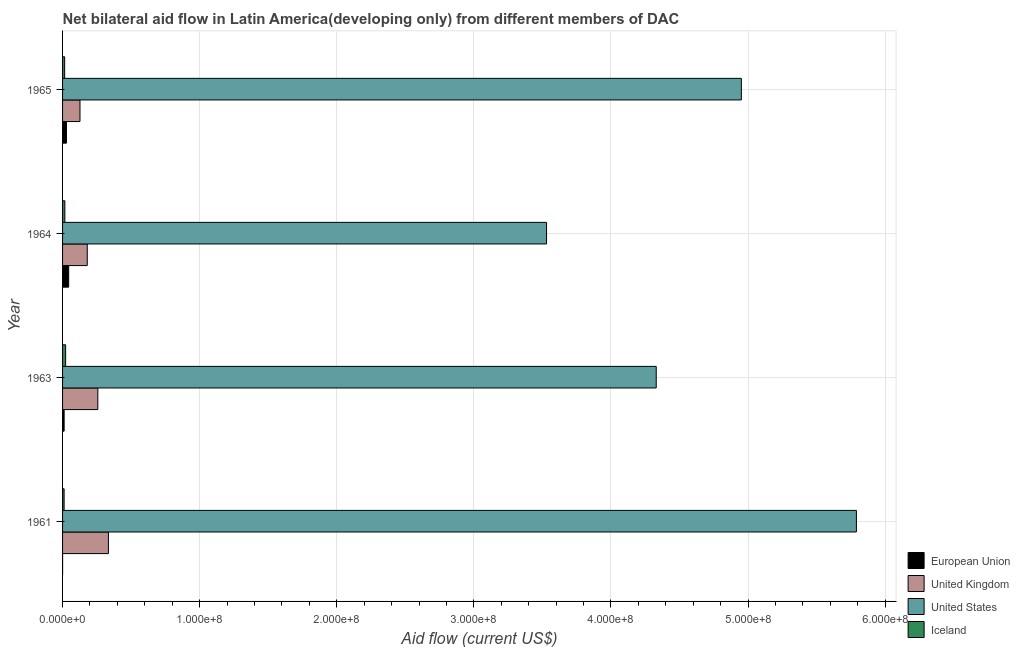Are the number of bars per tick equal to the number of legend labels?
Keep it short and to the point. Yes. Are the number of bars on each tick of the Y-axis equal?
Ensure brevity in your answer.  Yes. What is the label of the 2nd group of bars from the top?
Provide a succinct answer. 1964. In how many cases, is the number of bars for a given year not equal to the number of legend labels?
Make the answer very short. 0. What is the amount of aid given by us in 1965?
Provide a succinct answer. 4.95e+08. Across all years, what is the maximum amount of aid given by iceland?
Ensure brevity in your answer.  2.23e+06. Across all years, what is the minimum amount of aid given by iceland?
Your answer should be very brief. 1.13e+06. In which year was the amount of aid given by eu minimum?
Make the answer very short. 1961. What is the total amount of aid given by uk in the graph?
Your response must be concise. 8.99e+07. What is the difference between the amount of aid given by eu in 1964 and that in 1965?
Offer a terse response. 1.60e+06. What is the difference between the amount of aid given by uk in 1965 and the amount of aid given by eu in 1961?
Provide a succinct answer. 1.27e+07. What is the average amount of aid given by us per year?
Make the answer very short. 4.65e+08. In the year 1965, what is the difference between the amount of aid given by uk and amount of aid given by eu?
Your answer should be compact. 9.86e+06. In how many years, is the amount of aid given by uk greater than 440000000 US$?
Your answer should be compact. 0. What is the ratio of the amount of aid given by us in 1961 to that in 1964?
Your answer should be very brief. 1.64. Is the amount of aid given by us in 1961 less than that in 1965?
Your answer should be very brief. No. Is the difference between the amount of aid given by iceland in 1964 and 1965 greater than the difference between the amount of aid given by uk in 1964 and 1965?
Provide a succinct answer. No. What is the difference between the highest and the second highest amount of aid given by us?
Make the answer very short. 8.39e+07. What is the difference between the highest and the lowest amount of aid given by eu?
Ensure brevity in your answer.  4.44e+06. Is it the case that in every year, the sum of the amount of aid given by uk and amount of aid given by iceland is greater than the sum of amount of aid given by us and amount of aid given by eu?
Your answer should be compact. No. What does the 1st bar from the bottom in 1964 represents?
Keep it short and to the point. European Union. Is it the case that in every year, the sum of the amount of aid given by eu and amount of aid given by uk is greater than the amount of aid given by us?
Make the answer very short. No. How many bars are there?
Provide a succinct answer. 16. What is the difference between two consecutive major ticks on the X-axis?
Offer a terse response. 1.00e+08. Where does the legend appear in the graph?
Provide a short and direct response. Bottom right. How many legend labels are there?
Your answer should be very brief. 4. What is the title of the graph?
Provide a succinct answer. Net bilateral aid flow in Latin America(developing only) from different members of DAC. What is the label or title of the Y-axis?
Make the answer very short. Year. What is the Aid flow (current US$) in European Union in 1961?
Give a very brief answer. 10000. What is the Aid flow (current US$) of United Kingdom in 1961?
Ensure brevity in your answer.  3.34e+07. What is the Aid flow (current US$) in United States in 1961?
Your answer should be compact. 5.79e+08. What is the Aid flow (current US$) in Iceland in 1961?
Provide a short and direct response. 1.13e+06. What is the Aid flow (current US$) of European Union in 1963?
Your response must be concise. 1.14e+06. What is the Aid flow (current US$) of United Kingdom in 1963?
Ensure brevity in your answer.  2.57e+07. What is the Aid flow (current US$) in United States in 1963?
Your answer should be very brief. 4.33e+08. What is the Aid flow (current US$) of Iceland in 1963?
Your response must be concise. 2.23e+06. What is the Aid flow (current US$) in European Union in 1964?
Your response must be concise. 4.45e+06. What is the Aid flow (current US$) in United Kingdom in 1964?
Give a very brief answer. 1.80e+07. What is the Aid flow (current US$) of United States in 1964?
Keep it short and to the point. 3.53e+08. What is the Aid flow (current US$) of Iceland in 1964?
Keep it short and to the point. 1.67e+06. What is the Aid flow (current US$) of European Union in 1965?
Your response must be concise. 2.85e+06. What is the Aid flow (current US$) in United Kingdom in 1965?
Offer a terse response. 1.27e+07. What is the Aid flow (current US$) of United States in 1965?
Offer a very short reply. 4.95e+08. What is the Aid flow (current US$) of Iceland in 1965?
Give a very brief answer. 1.53e+06. Across all years, what is the maximum Aid flow (current US$) in European Union?
Keep it short and to the point. 4.45e+06. Across all years, what is the maximum Aid flow (current US$) of United Kingdom?
Offer a very short reply. 3.34e+07. Across all years, what is the maximum Aid flow (current US$) in United States?
Ensure brevity in your answer.  5.79e+08. Across all years, what is the maximum Aid flow (current US$) of Iceland?
Your response must be concise. 2.23e+06. Across all years, what is the minimum Aid flow (current US$) of United Kingdom?
Keep it short and to the point. 1.27e+07. Across all years, what is the minimum Aid flow (current US$) in United States?
Provide a succinct answer. 3.53e+08. Across all years, what is the minimum Aid flow (current US$) in Iceland?
Provide a short and direct response. 1.13e+06. What is the total Aid flow (current US$) of European Union in the graph?
Give a very brief answer. 8.45e+06. What is the total Aid flow (current US$) in United Kingdom in the graph?
Your answer should be very brief. 8.99e+07. What is the total Aid flow (current US$) of United States in the graph?
Offer a terse response. 1.86e+09. What is the total Aid flow (current US$) of Iceland in the graph?
Keep it short and to the point. 6.56e+06. What is the difference between the Aid flow (current US$) in European Union in 1961 and that in 1963?
Make the answer very short. -1.13e+06. What is the difference between the Aid flow (current US$) of United Kingdom in 1961 and that in 1963?
Provide a short and direct response. 7.73e+06. What is the difference between the Aid flow (current US$) of United States in 1961 and that in 1963?
Your response must be concise. 1.46e+08. What is the difference between the Aid flow (current US$) in Iceland in 1961 and that in 1963?
Make the answer very short. -1.10e+06. What is the difference between the Aid flow (current US$) of European Union in 1961 and that in 1964?
Your answer should be compact. -4.44e+06. What is the difference between the Aid flow (current US$) of United Kingdom in 1961 and that in 1964?
Keep it short and to the point. 1.54e+07. What is the difference between the Aid flow (current US$) of United States in 1961 and that in 1964?
Keep it short and to the point. 2.26e+08. What is the difference between the Aid flow (current US$) in Iceland in 1961 and that in 1964?
Offer a very short reply. -5.40e+05. What is the difference between the Aid flow (current US$) of European Union in 1961 and that in 1965?
Your response must be concise. -2.84e+06. What is the difference between the Aid flow (current US$) of United Kingdom in 1961 and that in 1965?
Give a very brief answer. 2.07e+07. What is the difference between the Aid flow (current US$) of United States in 1961 and that in 1965?
Keep it short and to the point. 8.39e+07. What is the difference between the Aid flow (current US$) in Iceland in 1961 and that in 1965?
Offer a terse response. -4.00e+05. What is the difference between the Aid flow (current US$) of European Union in 1963 and that in 1964?
Provide a succinct answer. -3.31e+06. What is the difference between the Aid flow (current US$) of United Kingdom in 1963 and that in 1964?
Keep it short and to the point. 7.70e+06. What is the difference between the Aid flow (current US$) of United States in 1963 and that in 1964?
Give a very brief answer. 8.00e+07. What is the difference between the Aid flow (current US$) in Iceland in 1963 and that in 1964?
Offer a terse response. 5.60e+05. What is the difference between the Aid flow (current US$) of European Union in 1963 and that in 1965?
Offer a very short reply. -1.71e+06. What is the difference between the Aid flow (current US$) in United Kingdom in 1963 and that in 1965?
Your answer should be very brief. 1.30e+07. What is the difference between the Aid flow (current US$) in United States in 1963 and that in 1965?
Your answer should be compact. -6.21e+07. What is the difference between the Aid flow (current US$) in European Union in 1964 and that in 1965?
Give a very brief answer. 1.60e+06. What is the difference between the Aid flow (current US$) in United Kingdom in 1964 and that in 1965?
Your answer should be compact. 5.31e+06. What is the difference between the Aid flow (current US$) of United States in 1964 and that in 1965?
Ensure brevity in your answer.  -1.42e+08. What is the difference between the Aid flow (current US$) in Iceland in 1964 and that in 1965?
Make the answer very short. 1.40e+05. What is the difference between the Aid flow (current US$) in European Union in 1961 and the Aid flow (current US$) in United Kingdom in 1963?
Ensure brevity in your answer.  -2.57e+07. What is the difference between the Aid flow (current US$) in European Union in 1961 and the Aid flow (current US$) in United States in 1963?
Ensure brevity in your answer.  -4.33e+08. What is the difference between the Aid flow (current US$) in European Union in 1961 and the Aid flow (current US$) in Iceland in 1963?
Make the answer very short. -2.22e+06. What is the difference between the Aid flow (current US$) in United Kingdom in 1961 and the Aid flow (current US$) in United States in 1963?
Provide a short and direct response. -4.00e+08. What is the difference between the Aid flow (current US$) in United Kingdom in 1961 and the Aid flow (current US$) in Iceland in 1963?
Provide a short and direct response. 3.12e+07. What is the difference between the Aid flow (current US$) in United States in 1961 and the Aid flow (current US$) in Iceland in 1963?
Provide a succinct answer. 5.77e+08. What is the difference between the Aid flow (current US$) in European Union in 1961 and the Aid flow (current US$) in United Kingdom in 1964?
Make the answer very short. -1.80e+07. What is the difference between the Aid flow (current US$) in European Union in 1961 and the Aid flow (current US$) in United States in 1964?
Offer a terse response. -3.53e+08. What is the difference between the Aid flow (current US$) in European Union in 1961 and the Aid flow (current US$) in Iceland in 1964?
Offer a very short reply. -1.66e+06. What is the difference between the Aid flow (current US$) of United Kingdom in 1961 and the Aid flow (current US$) of United States in 1964?
Ensure brevity in your answer.  -3.20e+08. What is the difference between the Aid flow (current US$) in United Kingdom in 1961 and the Aid flow (current US$) in Iceland in 1964?
Make the answer very short. 3.18e+07. What is the difference between the Aid flow (current US$) of United States in 1961 and the Aid flow (current US$) of Iceland in 1964?
Ensure brevity in your answer.  5.77e+08. What is the difference between the Aid flow (current US$) in European Union in 1961 and the Aid flow (current US$) in United Kingdom in 1965?
Provide a succinct answer. -1.27e+07. What is the difference between the Aid flow (current US$) in European Union in 1961 and the Aid flow (current US$) in United States in 1965?
Your answer should be compact. -4.95e+08. What is the difference between the Aid flow (current US$) of European Union in 1961 and the Aid flow (current US$) of Iceland in 1965?
Give a very brief answer. -1.52e+06. What is the difference between the Aid flow (current US$) of United Kingdom in 1961 and the Aid flow (current US$) of United States in 1965?
Keep it short and to the point. -4.62e+08. What is the difference between the Aid flow (current US$) of United Kingdom in 1961 and the Aid flow (current US$) of Iceland in 1965?
Give a very brief answer. 3.19e+07. What is the difference between the Aid flow (current US$) of United States in 1961 and the Aid flow (current US$) of Iceland in 1965?
Provide a short and direct response. 5.77e+08. What is the difference between the Aid flow (current US$) of European Union in 1963 and the Aid flow (current US$) of United Kingdom in 1964?
Your answer should be very brief. -1.69e+07. What is the difference between the Aid flow (current US$) in European Union in 1963 and the Aid flow (current US$) in United States in 1964?
Ensure brevity in your answer.  -3.52e+08. What is the difference between the Aid flow (current US$) of European Union in 1963 and the Aid flow (current US$) of Iceland in 1964?
Offer a very short reply. -5.30e+05. What is the difference between the Aid flow (current US$) of United Kingdom in 1963 and the Aid flow (current US$) of United States in 1964?
Give a very brief answer. -3.27e+08. What is the difference between the Aid flow (current US$) of United Kingdom in 1963 and the Aid flow (current US$) of Iceland in 1964?
Provide a short and direct response. 2.40e+07. What is the difference between the Aid flow (current US$) in United States in 1963 and the Aid flow (current US$) in Iceland in 1964?
Offer a terse response. 4.31e+08. What is the difference between the Aid flow (current US$) of European Union in 1963 and the Aid flow (current US$) of United Kingdom in 1965?
Provide a succinct answer. -1.16e+07. What is the difference between the Aid flow (current US$) of European Union in 1963 and the Aid flow (current US$) of United States in 1965?
Make the answer very short. -4.94e+08. What is the difference between the Aid flow (current US$) of European Union in 1963 and the Aid flow (current US$) of Iceland in 1965?
Give a very brief answer. -3.90e+05. What is the difference between the Aid flow (current US$) in United Kingdom in 1963 and the Aid flow (current US$) in United States in 1965?
Your answer should be very brief. -4.69e+08. What is the difference between the Aid flow (current US$) in United Kingdom in 1963 and the Aid flow (current US$) in Iceland in 1965?
Give a very brief answer. 2.42e+07. What is the difference between the Aid flow (current US$) of United States in 1963 and the Aid flow (current US$) of Iceland in 1965?
Give a very brief answer. 4.31e+08. What is the difference between the Aid flow (current US$) in European Union in 1964 and the Aid flow (current US$) in United Kingdom in 1965?
Ensure brevity in your answer.  -8.26e+06. What is the difference between the Aid flow (current US$) of European Union in 1964 and the Aid flow (current US$) of United States in 1965?
Your answer should be compact. -4.91e+08. What is the difference between the Aid flow (current US$) in European Union in 1964 and the Aid flow (current US$) in Iceland in 1965?
Give a very brief answer. 2.92e+06. What is the difference between the Aid flow (current US$) of United Kingdom in 1964 and the Aid flow (current US$) of United States in 1965?
Offer a terse response. -4.77e+08. What is the difference between the Aid flow (current US$) of United Kingdom in 1964 and the Aid flow (current US$) of Iceland in 1965?
Make the answer very short. 1.65e+07. What is the difference between the Aid flow (current US$) in United States in 1964 and the Aid flow (current US$) in Iceland in 1965?
Offer a terse response. 3.51e+08. What is the average Aid flow (current US$) of European Union per year?
Make the answer very short. 2.11e+06. What is the average Aid flow (current US$) in United Kingdom per year?
Make the answer very short. 2.25e+07. What is the average Aid flow (current US$) of United States per year?
Provide a succinct answer. 4.65e+08. What is the average Aid flow (current US$) of Iceland per year?
Your answer should be compact. 1.64e+06. In the year 1961, what is the difference between the Aid flow (current US$) of European Union and Aid flow (current US$) of United Kingdom?
Provide a succinct answer. -3.34e+07. In the year 1961, what is the difference between the Aid flow (current US$) of European Union and Aid flow (current US$) of United States?
Your response must be concise. -5.79e+08. In the year 1961, what is the difference between the Aid flow (current US$) in European Union and Aid flow (current US$) in Iceland?
Offer a very short reply. -1.12e+06. In the year 1961, what is the difference between the Aid flow (current US$) in United Kingdom and Aid flow (current US$) in United States?
Offer a terse response. -5.46e+08. In the year 1961, what is the difference between the Aid flow (current US$) of United Kingdom and Aid flow (current US$) of Iceland?
Your response must be concise. 3.23e+07. In the year 1961, what is the difference between the Aid flow (current US$) of United States and Aid flow (current US$) of Iceland?
Offer a very short reply. 5.78e+08. In the year 1963, what is the difference between the Aid flow (current US$) in European Union and Aid flow (current US$) in United Kingdom?
Provide a succinct answer. -2.46e+07. In the year 1963, what is the difference between the Aid flow (current US$) of European Union and Aid flow (current US$) of United States?
Ensure brevity in your answer.  -4.32e+08. In the year 1963, what is the difference between the Aid flow (current US$) in European Union and Aid flow (current US$) in Iceland?
Provide a succinct answer. -1.09e+06. In the year 1963, what is the difference between the Aid flow (current US$) in United Kingdom and Aid flow (current US$) in United States?
Offer a very short reply. -4.07e+08. In the year 1963, what is the difference between the Aid flow (current US$) of United Kingdom and Aid flow (current US$) of Iceland?
Make the answer very short. 2.35e+07. In the year 1963, what is the difference between the Aid flow (current US$) in United States and Aid flow (current US$) in Iceland?
Make the answer very short. 4.31e+08. In the year 1964, what is the difference between the Aid flow (current US$) of European Union and Aid flow (current US$) of United Kingdom?
Provide a succinct answer. -1.36e+07. In the year 1964, what is the difference between the Aid flow (current US$) in European Union and Aid flow (current US$) in United States?
Make the answer very short. -3.49e+08. In the year 1964, what is the difference between the Aid flow (current US$) in European Union and Aid flow (current US$) in Iceland?
Give a very brief answer. 2.78e+06. In the year 1964, what is the difference between the Aid flow (current US$) in United Kingdom and Aid flow (current US$) in United States?
Ensure brevity in your answer.  -3.35e+08. In the year 1964, what is the difference between the Aid flow (current US$) of United Kingdom and Aid flow (current US$) of Iceland?
Give a very brief answer. 1.64e+07. In the year 1964, what is the difference between the Aid flow (current US$) of United States and Aid flow (current US$) of Iceland?
Your answer should be compact. 3.51e+08. In the year 1965, what is the difference between the Aid flow (current US$) in European Union and Aid flow (current US$) in United Kingdom?
Offer a terse response. -9.86e+06. In the year 1965, what is the difference between the Aid flow (current US$) of European Union and Aid flow (current US$) of United States?
Your answer should be compact. -4.92e+08. In the year 1965, what is the difference between the Aid flow (current US$) in European Union and Aid flow (current US$) in Iceland?
Ensure brevity in your answer.  1.32e+06. In the year 1965, what is the difference between the Aid flow (current US$) in United Kingdom and Aid flow (current US$) in United States?
Your answer should be compact. -4.82e+08. In the year 1965, what is the difference between the Aid flow (current US$) in United Kingdom and Aid flow (current US$) in Iceland?
Your response must be concise. 1.12e+07. In the year 1965, what is the difference between the Aid flow (current US$) of United States and Aid flow (current US$) of Iceland?
Provide a short and direct response. 4.94e+08. What is the ratio of the Aid flow (current US$) in European Union in 1961 to that in 1963?
Ensure brevity in your answer.  0.01. What is the ratio of the Aid flow (current US$) in United Kingdom in 1961 to that in 1963?
Offer a terse response. 1.3. What is the ratio of the Aid flow (current US$) in United States in 1961 to that in 1963?
Offer a terse response. 1.34. What is the ratio of the Aid flow (current US$) of Iceland in 1961 to that in 1963?
Your answer should be very brief. 0.51. What is the ratio of the Aid flow (current US$) of European Union in 1961 to that in 1964?
Your answer should be compact. 0. What is the ratio of the Aid flow (current US$) in United Kingdom in 1961 to that in 1964?
Your answer should be compact. 1.86. What is the ratio of the Aid flow (current US$) of United States in 1961 to that in 1964?
Provide a short and direct response. 1.64. What is the ratio of the Aid flow (current US$) in Iceland in 1961 to that in 1964?
Keep it short and to the point. 0.68. What is the ratio of the Aid flow (current US$) of European Union in 1961 to that in 1965?
Offer a terse response. 0. What is the ratio of the Aid flow (current US$) in United Kingdom in 1961 to that in 1965?
Your answer should be compact. 2.63. What is the ratio of the Aid flow (current US$) in United States in 1961 to that in 1965?
Make the answer very short. 1.17. What is the ratio of the Aid flow (current US$) in Iceland in 1961 to that in 1965?
Your answer should be compact. 0.74. What is the ratio of the Aid flow (current US$) in European Union in 1963 to that in 1964?
Provide a short and direct response. 0.26. What is the ratio of the Aid flow (current US$) in United Kingdom in 1963 to that in 1964?
Offer a very short reply. 1.43. What is the ratio of the Aid flow (current US$) of United States in 1963 to that in 1964?
Give a very brief answer. 1.23. What is the ratio of the Aid flow (current US$) of Iceland in 1963 to that in 1964?
Provide a succinct answer. 1.34. What is the ratio of the Aid flow (current US$) of European Union in 1963 to that in 1965?
Your response must be concise. 0.4. What is the ratio of the Aid flow (current US$) of United Kingdom in 1963 to that in 1965?
Provide a succinct answer. 2.02. What is the ratio of the Aid flow (current US$) of United States in 1963 to that in 1965?
Your answer should be compact. 0.87. What is the ratio of the Aid flow (current US$) of Iceland in 1963 to that in 1965?
Offer a terse response. 1.46. What is the ratio of the Aid flow (current US$) of European Union in 1964 to that in 1965?
Provide a succinct answer. 1.56. What is the ratio of the Aid flow (current US$) in United Kingdom in 1964 to that in 1965?
Ensure brevity in your answer.  1.42. What is the ratio of the Aid flow (current US$) of United States in 1964 to that in 1965?
Keep it short and to the point. 0.71. What is the ratio of the Aid flow (current US$) of Iceland in 1964 to that in 1965?
Offer a terse response. 1.09. What is the difference between the highest and the second highest Aid flow (current US$) of European Union?
Your response must be concise. 1.60e+06. What is the difference between the highest and the second highest Aid flow (current US$) of United Kingdom?
Your answer should be very brief. 7.73e+06. What is the difference between the highest and the second highest Aid flow (current US$) of United States?
Provide a succinct answer. 8.39e+07. What is the difference between the highest and the second highest Aid flow (current US$) of Iceland?
Ensure brevity in your answer.  5.60e+05. What is the difference between the highest and the lowest Aid flow (current US$) in European Union?
Make the answer very short. 4.44e+06. What is the difference between the highest and the lowest Aid flow (current US$) of United Kingdom?
Keep it short and to the point. 2.07e+07. What is the difference between the highest and the lowest Aid flow (current US$) in United States?
Provide a short and direct response. 2.26e+08. What is the difference between the highest and the lowest Aid flow (current US$) in Iceland?
Keep it short and to the point. 1.10e+06. 